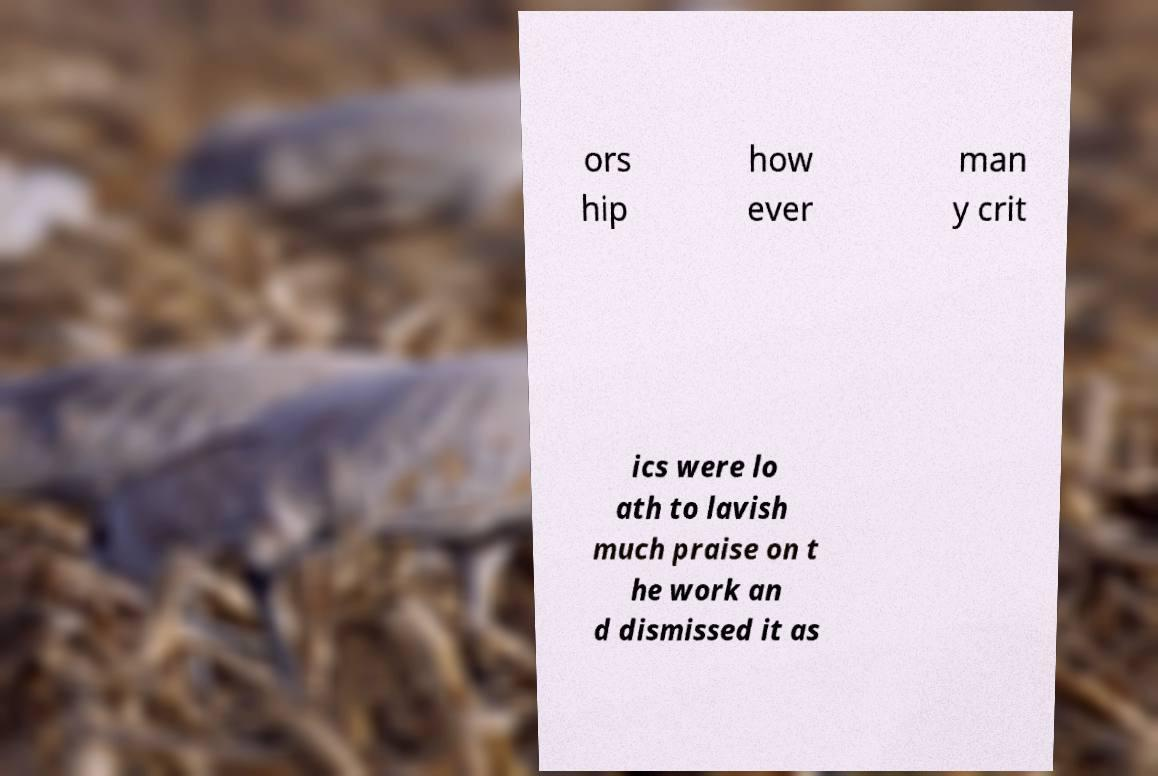What messages or text are displayed in this image? I need them in a readable, typed format. ors hip how ever man y crit ics were lo ath to lavish much praise on t he work an d dismissed it as 